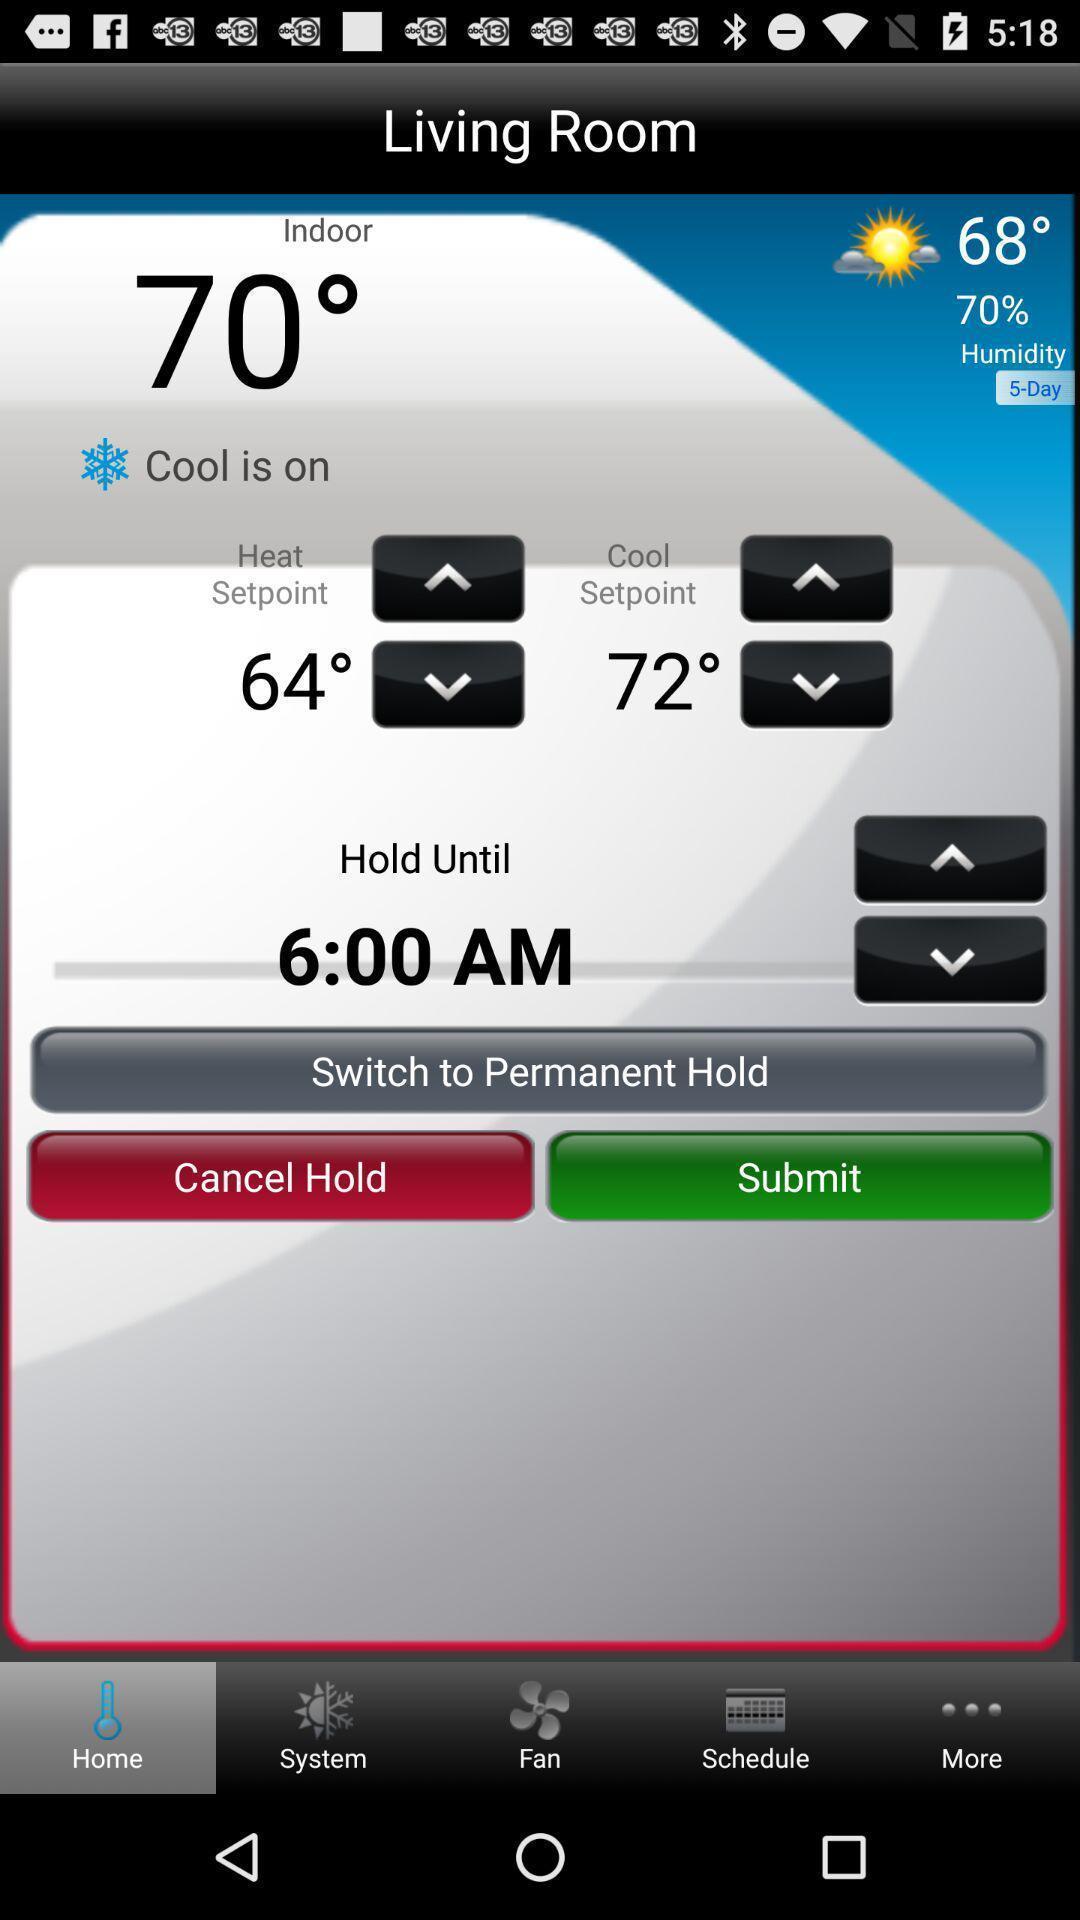Describe this image in words. Weather information showing in this page. 